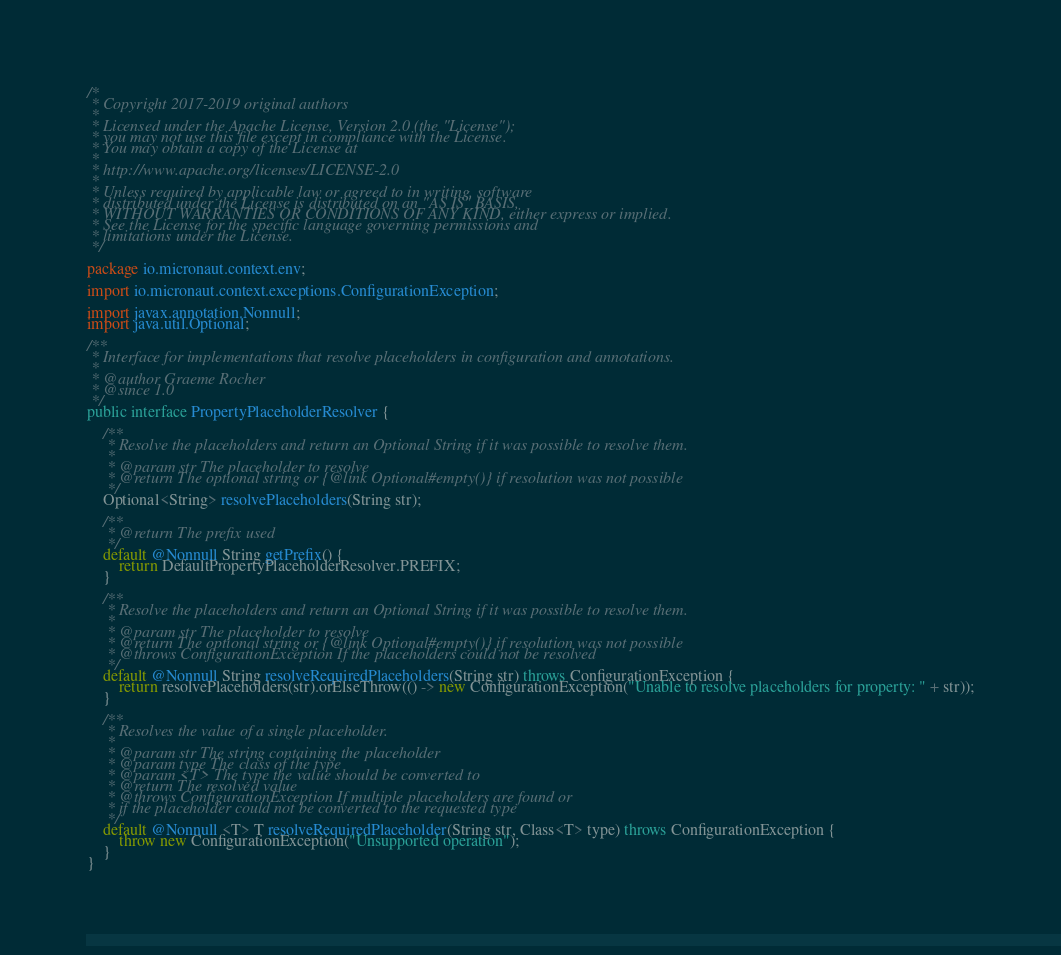<code> <loc_0><loc_0><loc_500><loc_500><_Java_>/*
 * Copyright 2017-2019 original authors
 *
 * Licensed under the Apache License, Version 2.0 (the "License");
 * you may not use this file except in compliance with the License.
 * You may obtain a copy of the License at
 *
 * http://www.apache.org/licenses/LICENSE-2.0
 *
 * Unless required by applicable law or agreed to in writing, software
 * distributed under the License is distributed on an "AS IS" BASIS,
 * WITHOUT WARRANTIES OR CONDITIONS OF ANY KIND, either express or implied.
 * See the License for the specific language governing permissions and
 * limitations under the License.
 */

package io.micronaut.context.env;

import io.micronaut.context.exceptions.ConfigurationException;

import javax.annotation.Nonnull;
import java.util.Optional;

/**
 * Interface for implementations that resolve placeholders in configuration and annotations.
 *
 * @author Graeme Rocher
 * @since 1.0
 */
public interface PropertyPlaceholderResolver {

    /**
     * Resolve the placeholders and return an Optional String if it was possible to resolve them.
     *
     * @param str The placeholder to resolve
     * @return The optional string or {@link Optional#empty()} if resolution was not possible
     */
    Optional<String> resolvePlaceholders(String str);

    /**
     * @return The prefix used
     */
    default @Nonnull String getPrefix() {
        return DefaultPropertyPlaceholderResolver.PREFIX;
    }

    /**
     * Resolve the placeholders and return an Optional String if it was possible to resolve them.
     *
     * @param str The placeholder to resolve
     * @return The optional string or {@link Optional#empty()} if resolution was not possible
     * @throws ConfigurationException If the placeholders could not be resolved
     */
    default @Nonnull String resolveRequiredPlaceholders(String str) throws ConfigurationException {
        return resolvePlaceholders(str).orElseThrow(() -> new ConfigurationException("Unable to resolve placeholders for property: " + str));
    }

    /**
     * Resolves the value of a single placeholder.
     *
     * @param str The string containing the placeholder
     * @param type The class of the type
     * @param <T> The type the value should be converted to
     * @return The resolved value
     * @throws ConfigurationException If multiple placeholders are found or
     * if the placeholder could not be converted to the requested type
     */
    default @Nonnull <T> T resolveRequiredPlaceholder(String str, Class<T> type) throws ConfigurationException {
        throw new ConfigurationException("Unsupported operation");
    }
}
</code> 